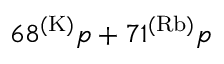<formula> <loc_0><loc_0><loc_500><loc_500>6 8 ^ { ( K ) } p + 7 1 ^ { ( R b ) } p</formula> 